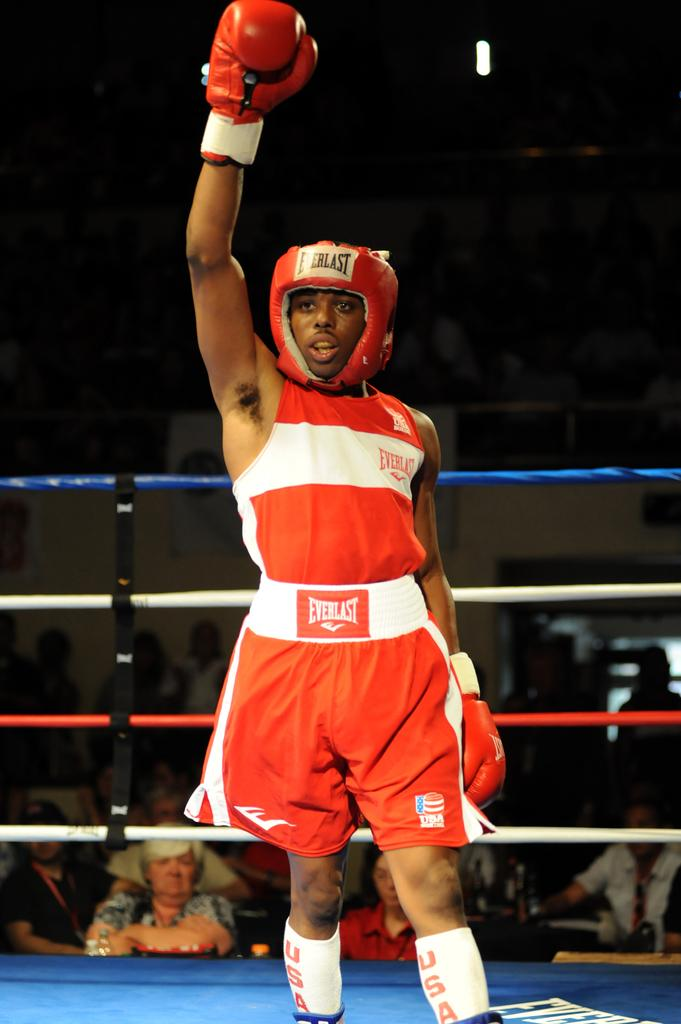Who is present in the image? There is a man in the image. What is the man doing in the image? The man is standing in a battle ring. What type of clothing is the man wearing? The man is wearing boxing dress. What protective gear is the man wearing? The man is wearing a boxing helmet and gloves. Can you describe the environment in the image? There are spectators in the background of the image. What type of smile can be seen on the man's face in the image? There is no smile visible on the man's face in the image, as he is wearing a boxing helmet that covers his facial expression. 